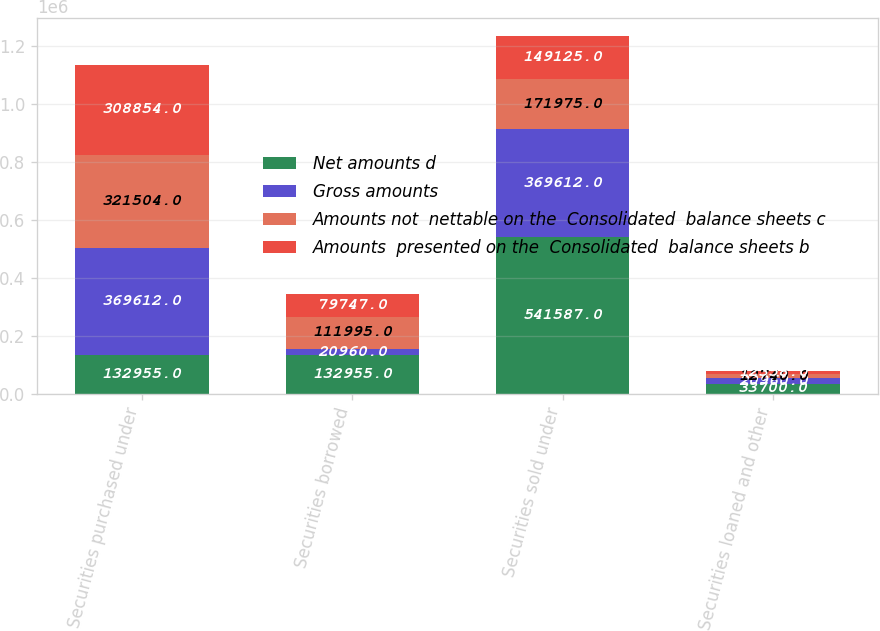Convert chart. <chart><loc_0><loc_0><loc_500><loc_500><stacked_bar_chart><ecel><fcel>Securities purchased under<fcel>Securities borrowed<fcel>Securities sold under<fcel>Securities loaned and other<nl><fcel>Net amounts d<fcel>132955<fcel>132955<fcel>541587<fcel>33700<nl><fcel>Gross amounts<fcel>369612<fcel>20960<fcel>369612<fcel>20960<nl><fcel>Amounts not  nettable on the  Consolidated  balance sheets c<fcel>321504<fcel>111995<fcel>171975<fcel>12740<nl><fcel>Amounts  presented on the  Consolidated  balance sheets b<fcel>308854<fcel>79747<fcel>149125<fcel>12358<nl></chart> 